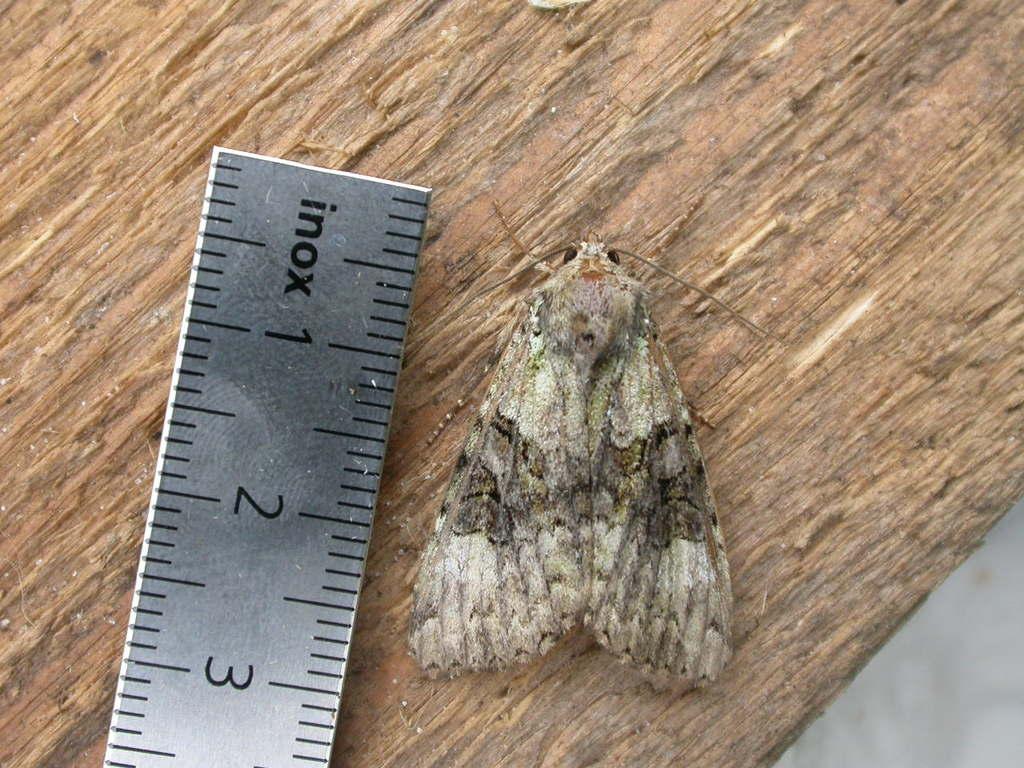What is the word on the ruler?
Ensure brevity in your answer.  Inox. 